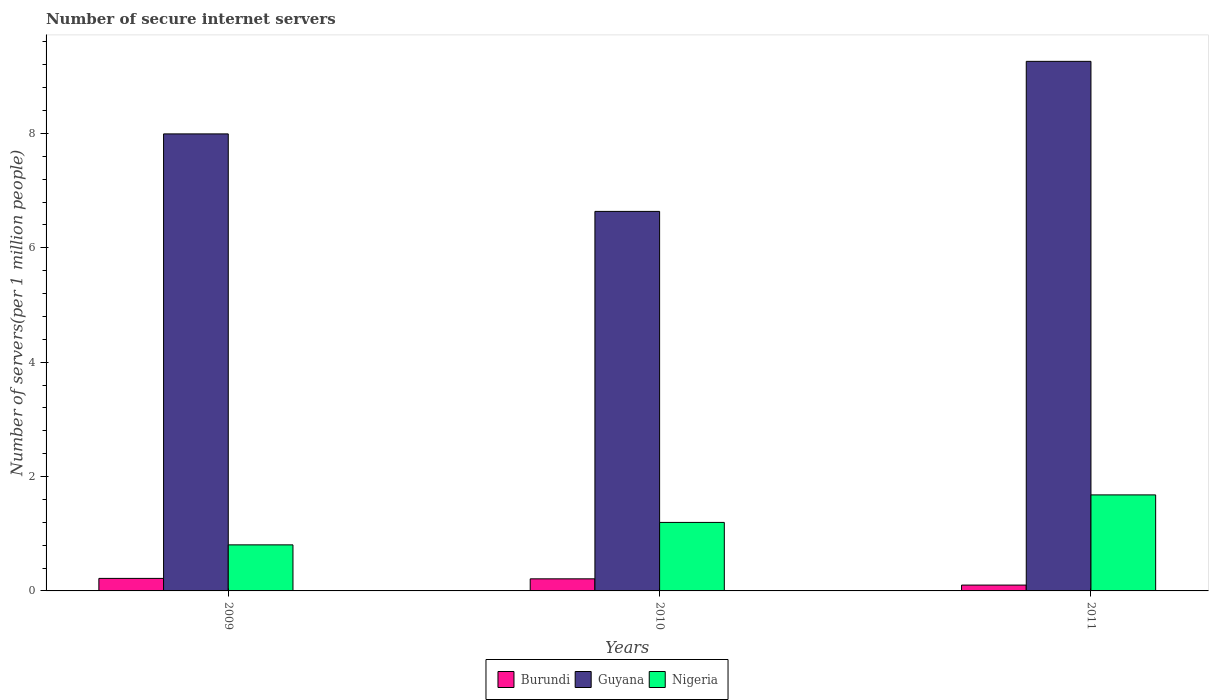How many groups of bars are there?
Ensure brevity in your answer.  3. Are the number of bars per tick equal to the number of legend labels?
Offer a terse response. Yes. Are the number of bars on each tick of the X-axis equal?
Provide a short and direct response. Yes. How many bars are there on the 1st tick from the right?
Keep it short and to the point. 3. What is the label of the 2nd group of bars from the left?
Your response must be concise. 2010. In how many cases, is the number of bars for a given year not equal to the number of legend labels?
Keep it short and to the point. 0. What is the number of secure internet servers in Burundi in 2011?
Make the answer very short. 0.1. Across all years, what is the maximum number of secure internet servers in Nigeria?
Provide a short and direct response. 1.68. Across all years, what is the minimum number of secure internet servers in Guyana?
Ensure brevity in your answer.  6.64. In which year was the number of secure internet servers in Nigeria maximum?
Offer a terse response. 2011. In which year was the number of secure internet servers in Guyana minimum?
Your answer should be compact. 2010. What is the total number of secure internet servers in Nigeria in the graph?
Your answer should be compact. 3.68. What is the difference between the number of secure internet servers in Guyana in 2010 and that in 2011?
Your response must be concise. -2.62. What is the difference between the number of secure internet servers in Burundi in 2011 and the number of secure internet servers in Nigeria in 2010?
Offer a very short reply. -1.1. What is the average number of secure internet servers in Nigeria per year?
Keep it short and to the point. 1.23. In the year 2011, what is the difference between the number of secure internet servers in Guyana and number of secure internet servers in Burundi?
Ensure brevity in your answer.  9.16. In how many years, is the number of secure internet servers in Nigeria greater than 6.4?
Offer a terse response. 0. What is the ratio of the number of secure internet servers in Burundi in 2009 to that in 2010?
Provide a short and direct response. 1.04. Is the number of secure internet servers in Nigeria in 2009 less than that in 2010?
Keep it short and to the point. Yes. Is the difference between the number of secure internet servers in Guyana in 2009 and 2010 greater than the difference between the number of secure internet servers in Burundi in 2009 and 2010?
Give a very brief answer. Yes. What is the difference between the highest and the second highest number of secure internet servers in Burundi?
Offer a very short reply. 0.01. What is the difference between the highest and the lowest number of secure internet servers in Nigeria?
Ensure brevity in your answer.  0.87. In how many years, is the number of secure internet servers in Burundi greater than the average number of secure internet servers in Burundi taken over all years?
Offer a very short reply. 2. Is the sum of the number of secure internet servers in Nigeria in 2009 and 2010 greater than the maximum number of secure internet servers in Burundi across all years?
Make the answer very short. Yes. What does the 1st bar from the left in 2011 represents?
Provide a succinct answer. Burundi. What does the 2nd bar from the right in 2011 represents?
Give a very brief answer. Guyana. Is it the case that in every year, the sum of the number of secure internet servers in Burundi and number of secure internet servers in Guyana is greater than the number of secure internet servers in Nigeria?
Your answer should be very brief. Yes. What is the difference between two consecutive major ticks on the Y-axis?
Your response must be concise. 2. Does the graph contain any zero values?
Keep it short and to the point. No. Does the graph contain grids?
Ensure brevity in your answer.  No. How are the legend labels stacked?
Your response must be concise. Horizontal. What is the title of the graph?
Give a very brief answer. Number of secure internet servers. Does "Mauritius" appear as one of the legend labels in the graph?
Offer a very short reply. No. What is the label or title of the X-axis?
Make the answer very short. Years. What is the label or title of the Y-axis?
Provide a short and direct response. Number of servers(per 1 million people). What is the Number of servers(per 1 million people) in Burundi in 2009?
Your answer should be very brief. 0.22. What is the Number of servers(per 1 million people) of Guyana in 2009?
Provide a succinct answer. 7.99. What is the Number of servers(per 1 million people) of Nigeria in 2009?
Your response must be concise. 0.81. What is the Number of servers(per 1 million people) of Burundi in 2010?
Make the answer very short. 0.21. What is the Number of servers(per 1 million people) in Guyana in 2010?
Offer a very short reply. 6.64. What is the Number of servers(per 1 million people) of Nigeria in 2010?
Your answer should be compact. 1.2. What is the Number of servers(per 1 million people) of Burundi in 2011?
Your answer should be very brief. 0.1. What is the Number of servers(per 1 million people) in Guyana in 2011?
Ensure brevity in your answer.  9.26. What is the Number of servers(per 1 million people) of Nigeria in 2011?
Make the answer very short. 1.68. Across all years, what is the maximum Number of servers(per 1 million people) in Burundi?
Provide a succinct answer. 0.22. Across all years, what is the maximum Number of servers(per 1 million people) in Guyana?
Give a very brief answer. 9.26. Across all years, what is the maximum Number of servers(per 1 million people) of Nigeria?
Offer a very short reply. 1.68. Across all years, what is the minimum Number of servers(per 1 million people) in Burundi?
Your answer should be very brief. 0.1. Across all years, what is the minimum Number of servers(per 1 million people) of Guyana?
Provide a short and direct response. 6.64. Across all years, what is the minimum Number of servers(per 1 million people) in Nigeria?
Keep it short and to the point. 0.81. What is the total Number of servers(per 1 million people) of Burundi in the graph?
Keep it short and to the point. 0.53. What is the total Number of servers(per 1 million people) in Guyana in the graph?
Offer a terse response. 23.89. What is the total Number of servers(per 1 million people) in Nigeria in the graph?
Offer a terse response. 3.68. What is the difference between the Number of servers(per 1 million people) of Burundi in 2009 and that in 2010?
Give a very brief answer. 0.01. What is the difference between the Number of servers(per 1 million people) in Guyana in 2009 and that in 2010?
Your answer should be compact. 1.36. What is the difference between the Number of servers(per 1 million people) of Nigeria in 2009 and that in 2010?
Your answer should be compact. -0.39. What is the difference between the Number of servers(per 1 million people) in Burundi in 2009 and that in 2011?
Your answer should be very brief. 0.12. What is the difference between the Number of servers(per 1 million people) of Guyana in 2009 and that in 2011?
Your response must be concise. -1.27. What is the difference between the Number of servers(per 1 million people) of Nigeria in 2009 and that in 2011?
Give a very brief answer. -0.87. What is the difference between the Number of servers(per 1 million people) of Burundi in 2010 and that in 2011?
Ensure brevity in your answer.  0.11. What is the difference between the Number of servers(per 1 million people) in Guyana in 2010 and that in 2011?
Your response must be concise. -2.62. What is the difference between the Number of servers(per 1 million people) of Nigeria in 2010 and that in 2011?
Your answer should be compact. -0.48. What is the difference between the Number of servers(per 1 million people) of Burundi in 2009 and the Number of servers(per 1 million people) of Guyana in 2010?
Your answer should be compact. -6.42. What is the difference between the Number of servers(per 1 million people) in Burundi in 2009 and the Number of servers(per 1 million people) in Nigeria in 2010?
Provide a short and direct response. -0.98. What is the difference between the Number of servers(per 1 million people) of Guyana in 2009 and the Number of servers(per 1 million people) of Nigeria in 2010?
Your answer should be compact. 6.79. What is the difference between the Number of servers(per 1 million people) of Burundi in 2009 and the Number of servers(per 1 million people) of Guyana in 2011?
Offer a terse response. -9.04. What is the difference between the Number of servers(per 1 million people) in Burundi in 2009 and the Number of servers(per 1 million people) in Nigeria in 2011?
Your answer should be very brief. -1.46. What is the difference between the Number of servers(per 1 million people) in Guyana in 2009 and the Number of servers(per 1 million people) in Nigeria in 2011?
Offer a very short reply. 6.31. What is the difference between the Number of servers(per 1 million people) of Burundi in 2010 and the Number of servers(per 1 million people) of Guyana in 2011?
Make the answer very short. -9.05. What is the difference between the Number of servers(per 1 million people) of Burundi in 2010 and the Number of servers(per 1 million people) of Nigeria in 2011?
Your response must be concise. -1.47. What is the difference between the Number of servers(per 1 million people) of Guyana in 2010 and the Number of servers(per 1 million people) of Nigeria in 2011?
Your answer should be compact. 4.96. What is the average Number of servers(per 1 million people) of Burundi per year?
Keep it short and to the point. 0.18. What is the average Number of servers(per 1 million people) in Guyana per year?
Offer a terse response. 7.96. What is the average Number of servers(per 1 million people) in Nigeria per year?
Your answer should be very brief. 1.23. In the year 2009, what is the difference between the Number of servers(per 1 million people) of Burundi and Number of servers(per 1 million people) of Guyana?
Your answer should be compact. -7.77. In the year 2009, what is the difference between the Number of servers(per 1 million people) in Burundi and Number of servers(per 1 million people) in Nigeria?
Offer a terse response. -0.59. In the year 2009, what is the difference between the Number of servers(per 1 million people) of Guyana and Number of servers(per 1 million people) of Nigeria?
Provide a short and direct response. 7.19. In the year 2010, what is the difference between the Number of servers(per 1 million people) in Burundi and Number of servers(per 1 million people) in Guyana?
Your answer should be compact. -6.43. In the year 2010, what is the difference between the Number of servers(per 1 million people) in Burundi and Number of servers(per 1 million people) in Nigeria?
Provide a succinct answer. -0.99. In the year 2010, what is the difference between the Number of servers(per 1 million people) in Guyana and Number of servers(per 1 million people) in Nigeria?
Provide a short and direct response. 5.44. In the year 2011, what is the difference between the Number of servers(per 1 million people) in Burundi and Number of servers(per 1 million people) in Guyana?
Make the answer very short. -9.16. In the year 2011, what is the difference between the Number of servers(per 1 million people) in Burundi and Number of servers(per 1 million people) in Nigeria?
Make the answer very short. -1.58. In the year 2011, what is the difference between the Number of servers(per 1 million people) in Guyana and Number of servers(per 1 million people) in Nigeria?
Give a very brief answer. 7.58. What is the ratio of the Number of servers(per 1 million people) of Burundi in 2009 to that in 2010?
Keep it short and to the point. 1.04. What is the ratio of the Number of servers(per 1 million people) in Guyana in 2009 to that in 2010?
Ensure brevity in your answer.  1.2. What is the ratio of the Number of servers(per 1 million people) in Nigeria in 2009 to that in 2010?
Keep it short and to the point. 0.67. What is the ratio of the Number of servers(per 1 million people) of Burundi in 2009 to that in 2011?
Your response must be concise. 2.14. What is the ratio of the Number of servers(per 1 million people) in Guyana in 2009 to that in 2011?
Provide a succinct answer. 0.86. What is the ratio of the Number of servers(per 1 million people) of Nigeria in 2009 to that in 2011?
Offer a very short reply. 0.48. What is the ratio of the Number of servers(per 1 million people) of Burundi in 2010 to that in 2011?
Your response must be concise. 2.07. What is the ratio of the Number of servers(per 1 million people) of Guyana in 2010 to that in 2011?
Keep it short and to the point. 0.72. What is the ratio of the Number of servers(per 1 million people) in Nigeria in 2010 to that in 2011?
Keep it short and to the point. 0.71. What is the difference between the highest and the second highest Number of servers(per 1 million people) of Burundi?
Offer a very short reply. 0.01. What is the difference between the highest and the second highest Number of servers(per 1 million people) of Guyana?
Provide a short and direct response. 1.27. What is the difference between the highest and the second highest Number of servers(per 1 million people) in Nigeria?
Keep it short and to the point. 0.48. What is the difference between the highest and the lowest Number of servers(per 1 million people) of Burundi?
Keep it short and to the point. 0.12. What is the difference between the highest and the lowest Number of servers(per 1 million people) in Guyana?
Your answer should be compact. 2.62. What is the difference between the highest and the lowest Number of servers(per 1 million people) in Nigeria?
Offer a very short reply. 0.87. 